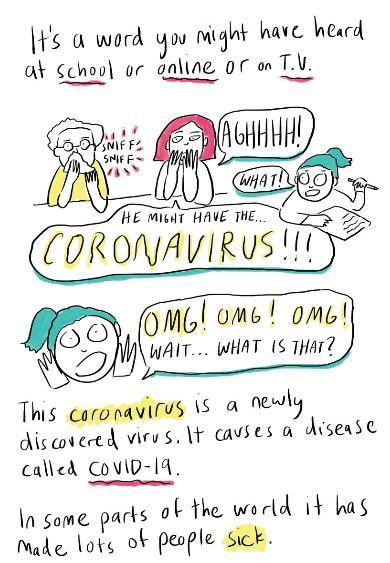Where do children mostly find out about coronavirus and covid-19?
Answer the question with a short phrase. School or online or on TV Which is the infectious agent that causes covid-19? Coronavirus What is coronavirus - bacteria fungi or virus? Virus 